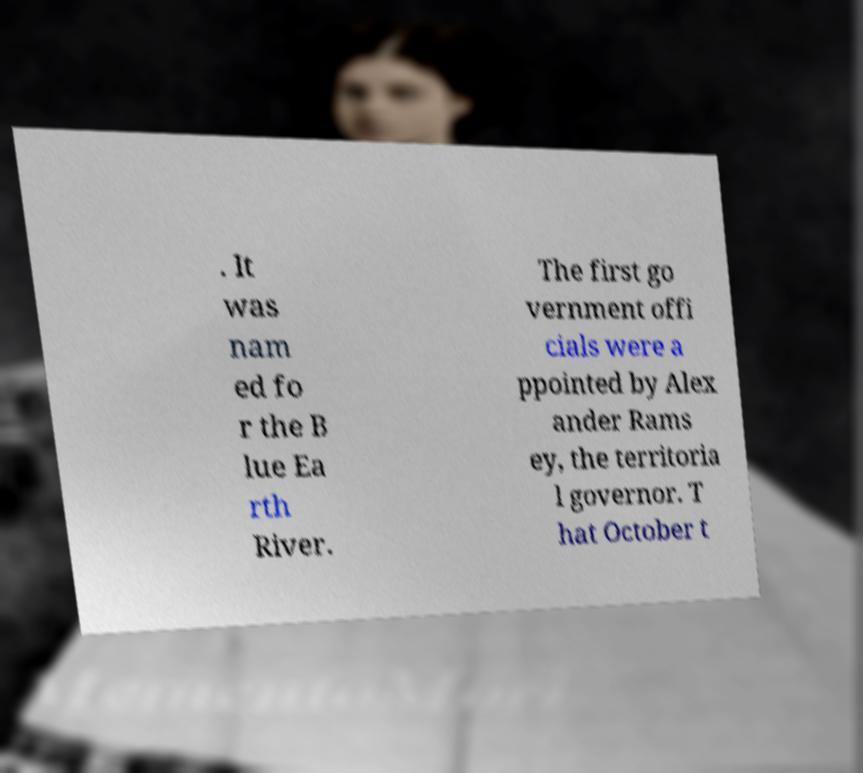Could you assist in decoding the text presented in this image and type it out clearly? . It was nam ed fo r the B lue Ea rth River. The first go vernment offi cials were a ppointed by Alex ander Rams ey, the territoria l governor. T hat October t 